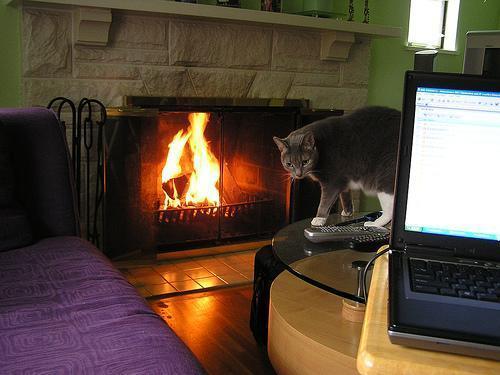How many animals are in the photo?
Give a very brief answer. 1. 